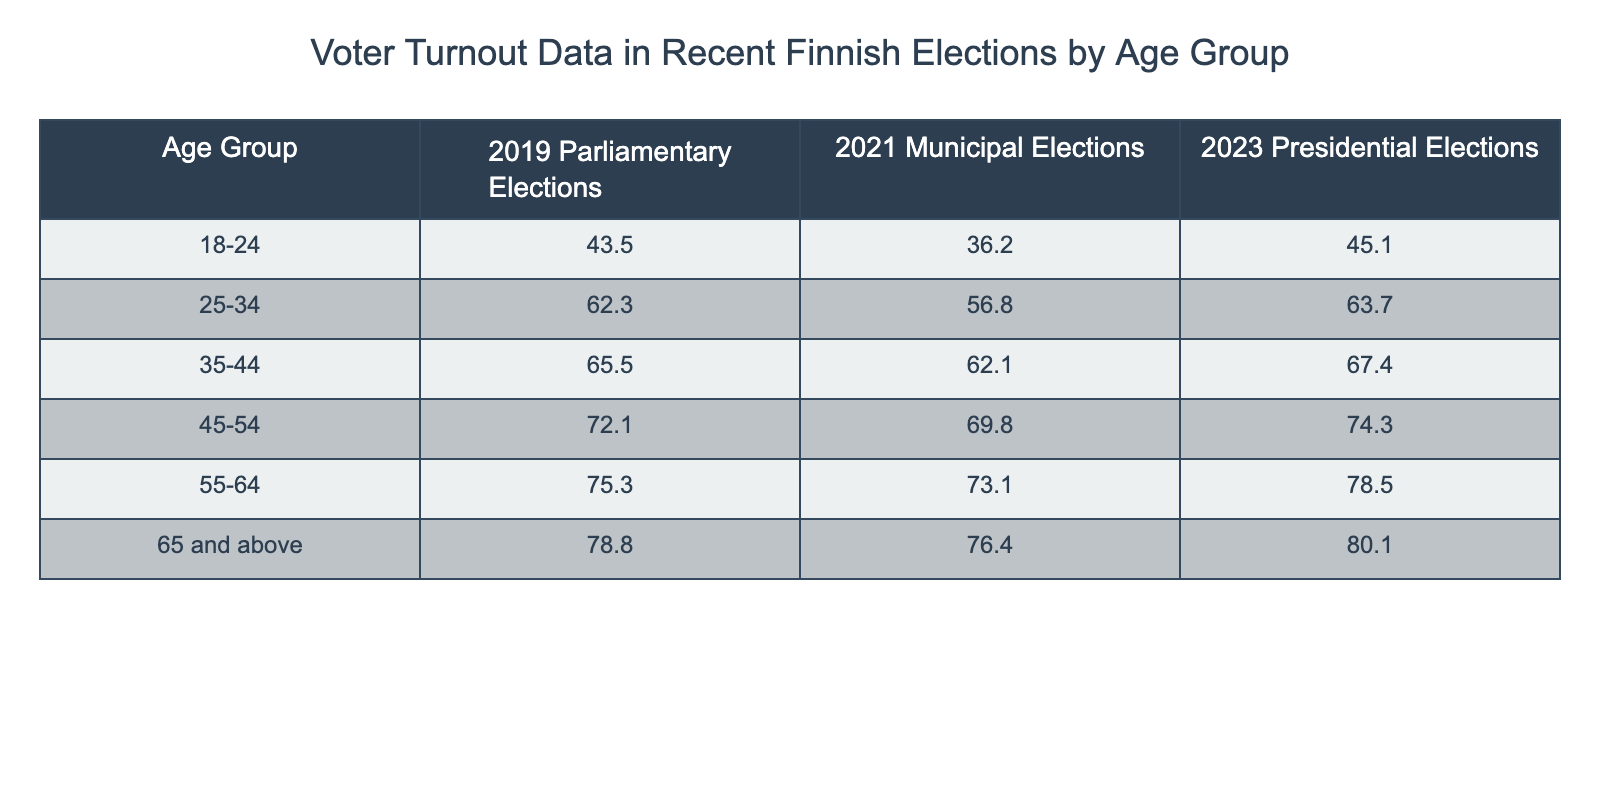What was the voter turnout for the 18-24 age group in the 2021 Municipal Elections? The table indicates that the voter turnout for the 18-24 age group in the 2021 Municipal Elections was 36.2%.
Answer: 36.2% Which age group had the highest voter turnout in the 2023 Presidential Elections? According to the table, the 65 and above age group had the highest voter turnout in the 2023 Presidential Elections at 80.1%.
Answer: 80.1% What is the difference in voter turnout for the 45-54 age group between the 2019 Parliamentary Elections and the 2023 Presidential Elections? The turnout for the 45-54 age group in the 2019 Parliamentary Elections was 72.1%, and in the 2023 Presidential Elections, it was 74.3%. The difference is 74.3 - 72.1 = 2.2%.
Answer: 2.2% Is the voter turnout for the 25-34 age group higher in the 2023 Presidential Elections compared to the 2021 Municipal Elections? In the 2023 Presidential Elections, the turnout for the 25-34 age group was 63.7%, while in the 2021 Municipal Elections, it was 56.8%. Since 63.7% is greater than 56.8%, the statement is true.
Answer: Yes What is the average voter turnout for the 55-64 age group across all three elections? The turnout for the 55-64 age group is 75.3% in the 2019 elections, 73.1% in the 2021 elections, and 78.5% in the 2023 elections. The average is calculated as (75.3 + 73.1 + 78.5) / 3 = 75.63%.
Answer: 75.63% 